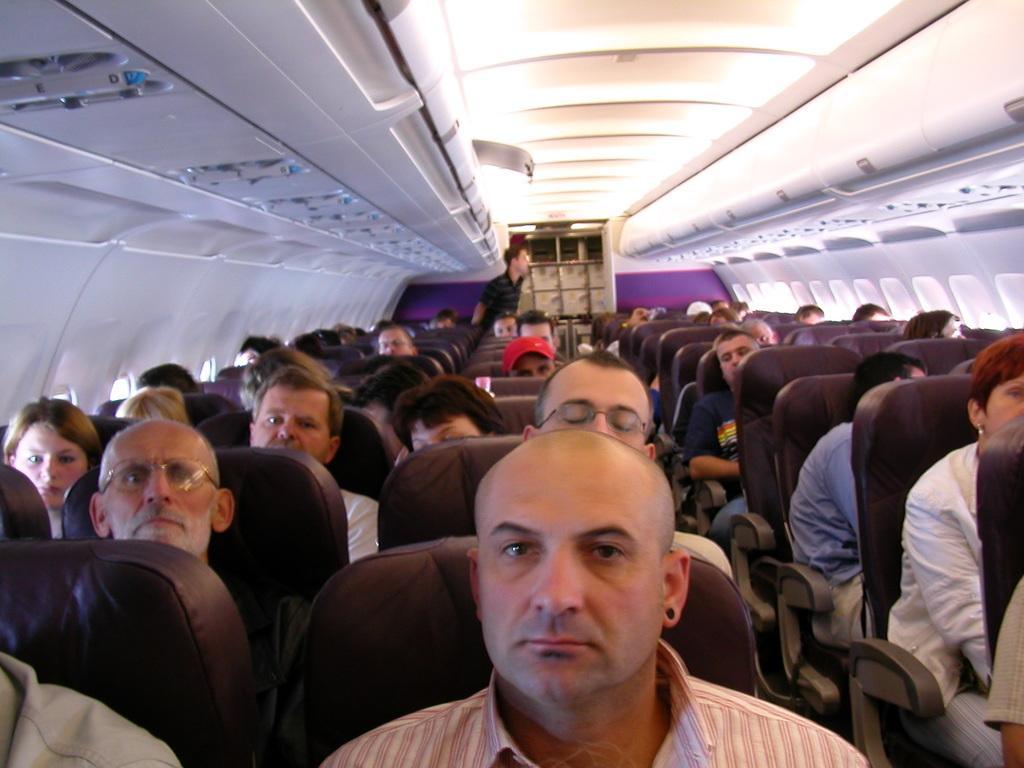Describe this image in one or two sentences. In this picture there is an inside view of the aircraft cabin. In the front there are some public sitting on the seat and looking to the camera. On the top we can see the lights in the cabin ceiling. 